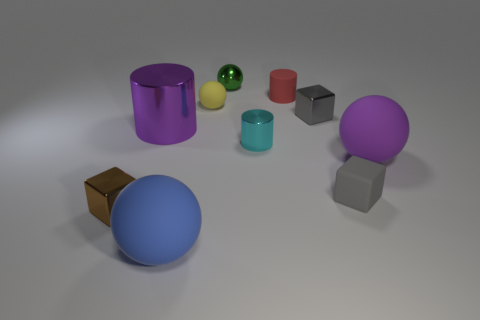There is a metallic block that is the same color as the tiny matte cube; what size is it?
Your response must be concise. Small. There is a big matte object that is the same color as the big metal cylinder; what is its shape?
Ensure brevity in your answer.  Sphere. What number of green shiny spheres are the same size as the green shiny object?
Keep it short and to the point. 0. What number of blue objects are big matte objects or big cylinders?
Your response must be concise. 1. What is the shape of the small cyan object that is behind the big ball that is in front of the purple sphere?
Your answer should be very brief. Cylinder. The blue matte thing that is the same size as the purple metal thing is what shape?
Provide a succinct answer. Sphere. Is there another object that has the same color as the big shiny object?
Offer a terse response. Yes. Is the number of small gray metal cubes that are behind the small yellow matte object the same as the number of yellow balls to the right of the large blue thing?
Your answer should be very brief. No. Do the tiny gray metallic object and the small gray thing that is in front of the cyan object have the same shape?
Your answer should be very brief. Yes. What number of other things are there of the same material as the large blue sphere
Offer a terse response. 4. 